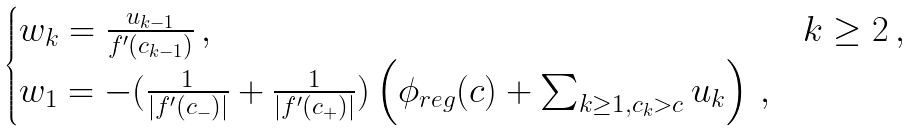Convert formula to latex. <formula><loc_0><loc_0><loc_500><loc_500>\begin{cases} w _ { k } = \frac { u _ { k - 1 } } { f ^ { \prime } ( c _ { k - 1 } ) } \, , & k \geq 2 \, , \\ w _ { 1 } = - ( \frac { 1 } { | f ^ { \prime } ( c _ { - } ) | } + \frac { 1 } { | f ^ { \prime } ( c _ { + } ) | } ) \left ( \phi _ { r e g } ( c ) + \sum _ { k \geq 1 , c _ { k } > c } u _ { k } \right ) \, , \\ \end{cases}</formula> 